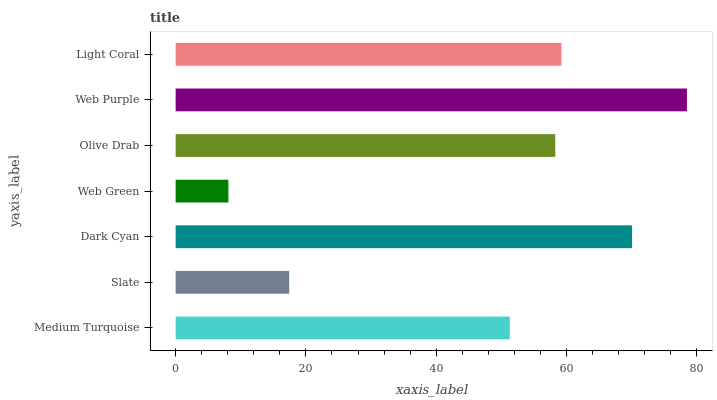Is Web Green the minimum?
Answer yes or no. Yes. Is Web Purple the maximum?
Answer yes or no. Yes. Is Slate the minimum?
Answer yes or no. No. Is Slate the maximum?
Answer yes or no. No. Is Medium Turquoise greater than Slate?
Answer yes or no. Yes. Is Slate less than Medium Turquoise?
Answer yes or no. Yes. Is Slate greater than Medium Turquoise?
Answer yes or no. No. Is Medium Turquoise less than Slate?
Answer yes or no. No. Is Olive Drab the high median?
Answer yes or no. Yes. Is Olive Drab the low median?
Answer yes or no. Yes. Is Web Green the high median?
Answer yes or no. No. Is Slate the low median?
Answer yes or no. No. 